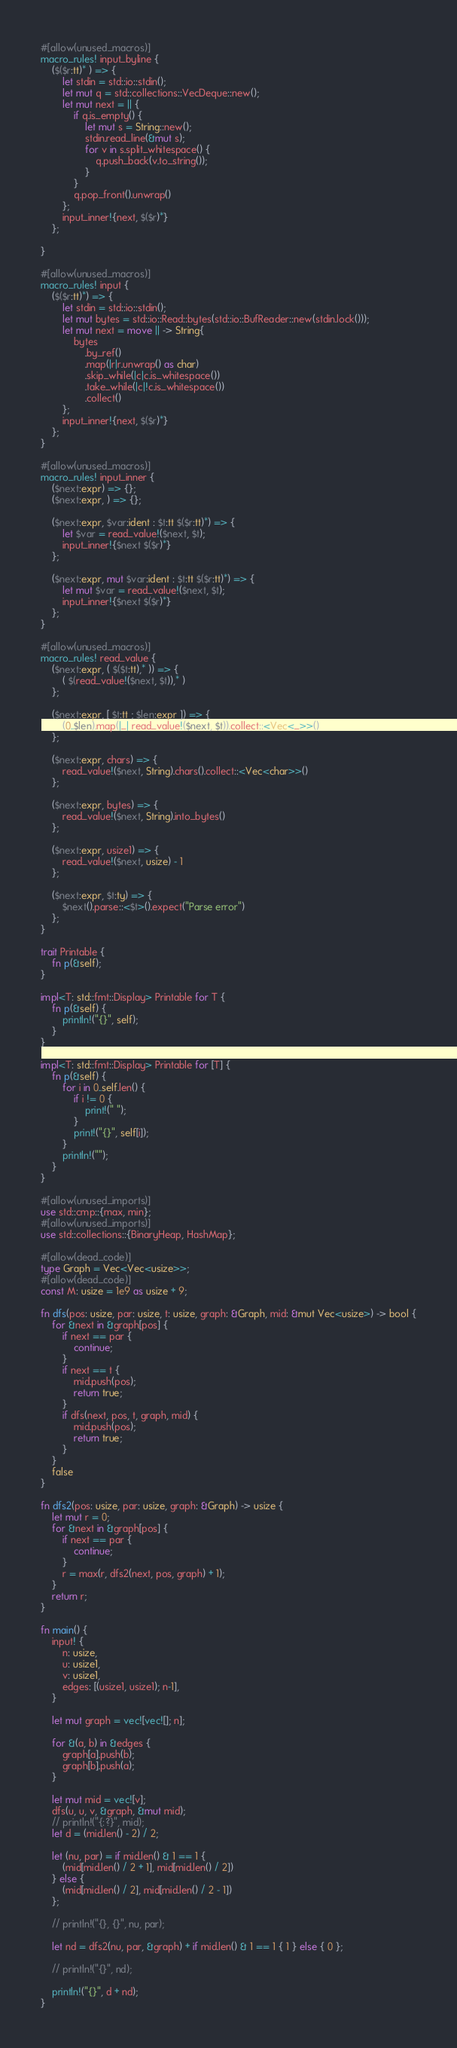Convert code to text. <code><loc_0><loc_0><loc_500><loc_500><_Rust_>#[allow(unused_macros)]
macro_rules! input_byline {
    ($($r:tt)* ) => {
        let stdin = std::io::stdin();
        let mut q = std::collections::VecDeque::new();
        let mut next = || {
            if q.is_empty() {
                let mut s = String::new();
                stdin.read_line(&mut s);
                for v in s.split_whitespace() {
                    q.push_back(v.to_string());
                }
            }
            q.pop_front().unwrap()
        };
        input_inner!{next, $($r)*}
    };

}

#[allow(unused_macros)]
macro_rules! input {
    ($($r:tt)*) => {
        let stdin = std::io::stdin();
        let mut bytes = std::io::Read::bytes(std::io::BufReader::new(stdin.lock()));
        let mut next = move || -> String{
            bytes
                .by_ref()
                .map(|r|r.unwrap() as char)
                .skip_while(|c|c.is_whitespace())
                .take_while(|c|!c.is_whitespace())
                .collect()
        };
        input_inner!{next, $($r)*}
    };
}

#[allow(unused_macros)]
macro_rules! input_inner {
    ($next:expr) => {};
    ($next:expr, ) => {};

    ($next:expr, $var:ident : $t:tt $($r:tt)*) => {
        let $var = read_value!($next, $t);
        input_inner!{$next $($r)*}
    };

    ($next:expr, mut $var:ident : $t:tt $($r:tt)*) => {
        let mut $var = read_value!($next, $t);
        input_inner!{$next $($r)*}
    };
}

#[allow(unused_macros)]
macro_rules! read_value {
    ($next:expr, ( $($t:tt),* )) => {
        ( $(read_value!($next, $t)),* )
    };

    ($next:expr, [ $t:tt ; $len:expr ]) => {
        (0..$len).map(|_| read_value!($next, $t)).collect::<Vec<_>>()
    };

    ($next:expr, chars) => {
        read_value!($next, String).chars().collect::<Vec<char>>()
    };

    ($next:expr, bytes) => {
        read_value!($next, String).into_bytes()
    };

    ($next:expr, usize1) => {
        read_value!($next, usize) - 1
    };

    ($next:expr, $t:ty) => {
        $next().parse::<$t>().expect("Parse error")
    };
}

trait Printable {
    fn p(&self);
}

impl<T: std::fmt::Display> Printable for T {
    fn p(&self) {
        println!("{}", self);
    }
}

impl<T: std::fmt::Display> Printable for [T] {
    fn p(&self) {
        for i in 0..self.len() {
            if i != 0 {
                print!(" ");
            }
            print!("{}", self[i]);
        }
        println!("");
    }
}

#[allow(unused_imports)]
use std::cmp::{max, min};
#[allow(unused_imports)]
use std::collections::{BinaryHeap, HashMap};

#[allow(dead_code)]
type Graph = Vec<Vec<usize>>;
#[allow(dead_code)]
const M: usize = 1e9 as usize + 9;

fn dfs(pos: usize, par: usize, t: usize, graph: &Graph, mid: &mut Vec<usize>) -> bool {
    for &next in &graph[pos] {
        if next == par {
            continue;
        }
        if next == t {
            mid.push(pos);
            return true;
        }
        if dfs(next, pos, t, graph, mid) {
            mid.push(pos);
            return true;
        }
    }
    false
}

fn dfs2(pos: usize, par: usize, graph: &Graph) -> usize {
    let mut r = 0;
    for &next in &graph[pos] {
        if next == par {
            continue;
        }
        r = max(r, dfs2(next, pos, graph) + 1);
    }
    return r;
}

fn main() {
    input! {
        n: usize,
        u: usize1,
        v: usize1,
        edges: [(usize1, usize1); n-1],
    }

    let mut graph = vec![vec![]; n];

    for &(a, b) in &edges {
        graph[a].push(b);
        graph[b].push(a);
    }

    let mut mid = vec![v];
    dfs(u, u, v, &graph, &mut mid);
    // println!("{:?}", mid);
    let d = (mid.len() - 2) / 2;

    let (nu, par) = if mid.len() & 1 == 1 {
        (mid[mid.len() / 2 + 1], mid[mid.len() / 2])
    } else {
        (mid[mid.len() / 2], mid[mid.len() / 2 - 1])
    };

    // println!("{}, {}", nu, par);

    let nd = dfs2(nu, par, &graph) + if mid.len() & 1 == 1 { 1 } else { 0 };

    // println!("{}", nd);

    println!("{}", d + nd);
}
</code> 